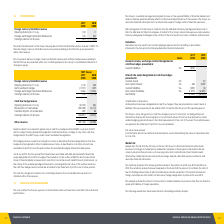According to National Storage Reit's financial document, Where is the hedging reserve used? record gains or losses on derivatives that are designated as cash flow hedges and recognised in other comprehensive income, as described in note 2(m).. The document states: "an tax legislation. The hedging reserve is used to record gains or losses on derivatives that are designated as cash flow hedges and recognised in oth..." Also, What was the cash outflow which reduced the Group's financial liability? According to the financial document, $22.9m. The relevant text states: "sh flow hedges. This resulted in a cash outflow of $22.9m which reduced the Group’s financial liability as presented in note 9.8. In accordance with AASB 9 Fi..." Also, What was the Net investment hedge in 2019 and 2018 respectively? The document shows two values: (1,591) and 1,007 (in thousands). From the document: "Net investment hedge (1,591) 1,007 Net investment hedge (1,591) 1,007..." Also, can you calculate: What was the average Foreign exchange translation differences for 2018 and 2019? To answer this question, I need to perform calculations using the financial data. The calculation is: (2,464 - 1,354) / 2, which equals 555 (in thousands). This is based on the information: "Foreign exchange translation differences 2,464 (1,354) Foreign exchange translation differences 2,464 (1,354)..." The key data points involved are: 1,354, 2,464. Additionally, In which year is the Net investment hedge negative? According to the financial document, 2019. The relevant text states: "2019 2018..." Also, can you calculate: What is the change in the Taxation impact on revaluation from 2018 to 2019? Based on the calculation: 290 - 84, the result is 206 (in thousands). This is based on the information: "Taxation impact on revaluation 290 84 Taxation impact on revaluation 290 84..." The key data points involved are: 290, 84. 